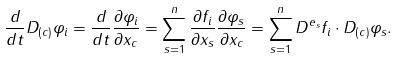Convert formula to latex. <formula><loc_0><loc_0><loc_500><loc_500>\frac { d } { d t } D _ { ( c ) } \varphi _ { i } = \frac { d } { d t } \frac { \partial \varphi _ { i } } { \partial x _ { c } } = \sum _ { s = 1 } ^ { n } \frac { \partial f _ { i } } { \partial x _ { s } } \frac { \partial \varphi _ { s } } { \partial x _ { c } } = \sum _ { s = 1 } ^ { n } D ^ { e _ { s } } f _ { i } \cdot D _ { ( c ) } \varphi _ { s } .</formula> 